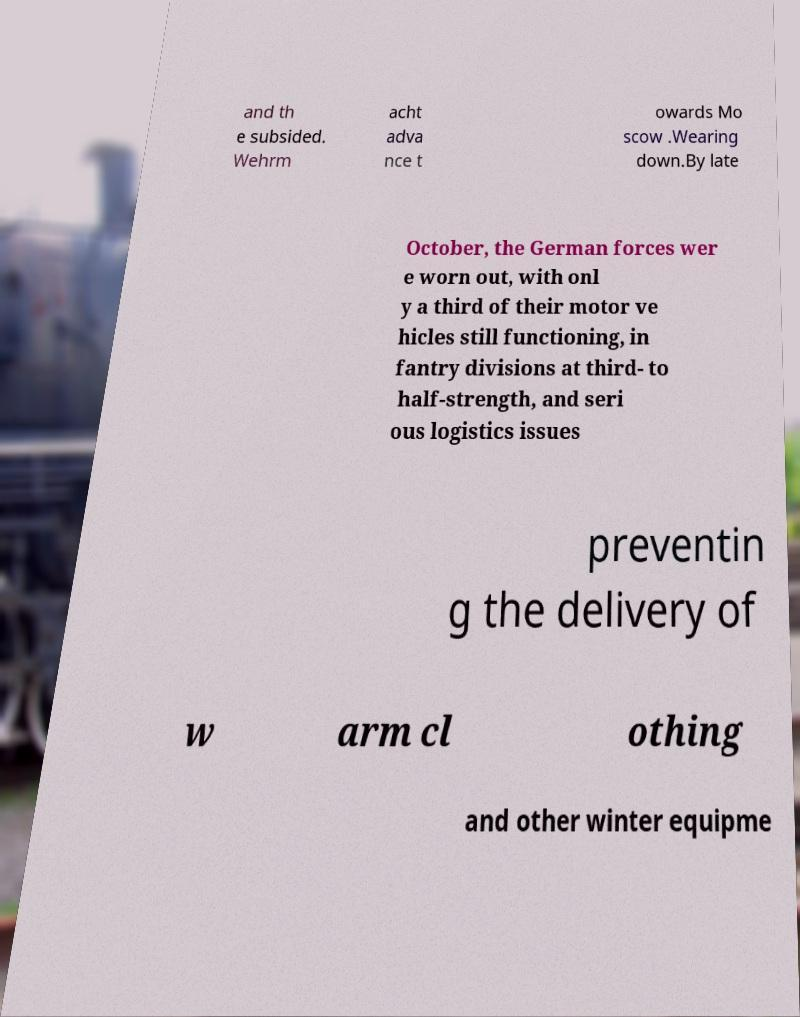I need the written content from this picture converted into text. Can you do that? and th e subsided. Wehrm acht adva nce t owards Mo scow .Wearing down.By late October, the German forces wer e worn out, with onl y a third of their motor ve hicles still functioning, in fantry divisions at third- to half-strength, and seri ous logistics issues preventin g the delivery of w arm cl othing and other winter equipme 